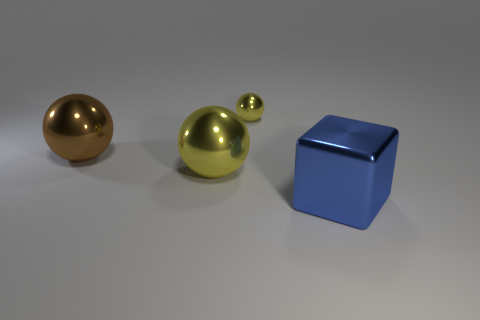Add 2 large blue cubes. How many objects exist? 6 Subtract all balls. How many objects are left? 1 Subtract 1 yellow spheres. How many objects are left? 3 Subtract all tiny balls. Subtract all metal spheres. How many objects are left? 0 Add 4 tiny yellow spheres. How many tiny yellow spheres are left? 5 Add 4 cyan shiny cubes. How many cyan shiny cubes exist? 4 